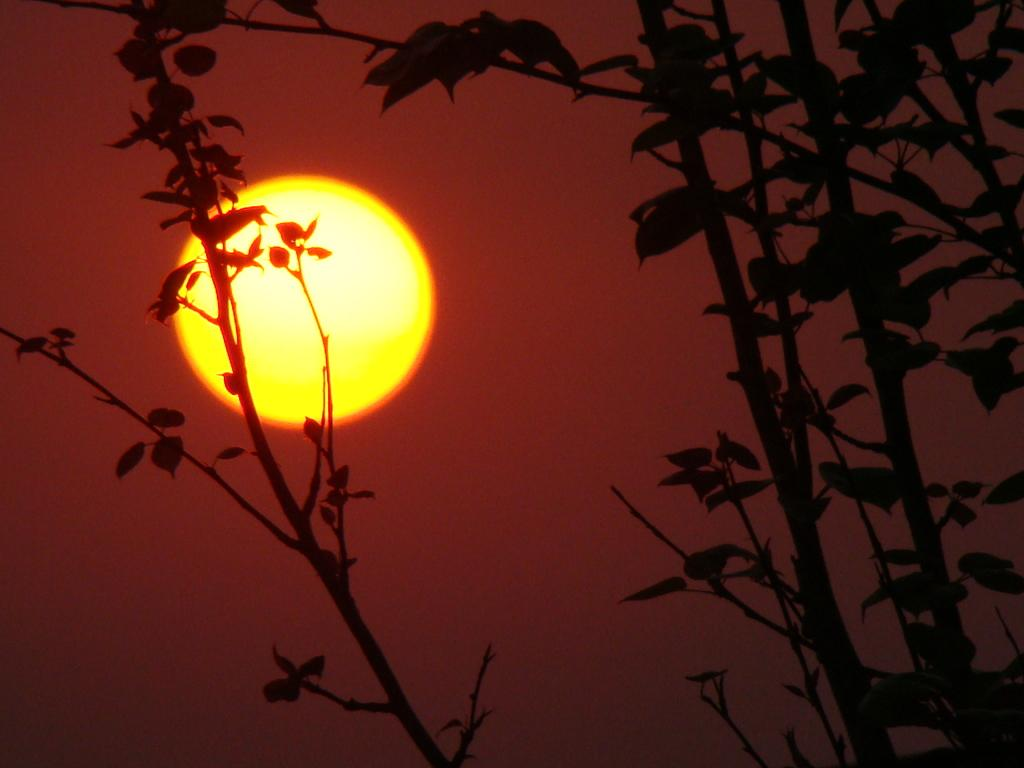What type of plant life is present in the image? There are stems with leaves in the image. What can be seen in the background of the image? There is a sky visible in the background of the image. What celestial body is observable in the sky? The sun is observable in the sky. What type of sound can be heard coming from the tiger in the image? There is no tiger present in the image, so it is not possible to determine what, if any, sound might be heard. 